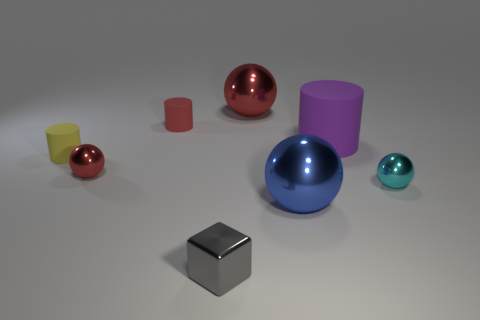How many things are either small gray cubes or things left of the big matte thing? In the image, there is one small gray cube. If we look at the objects positioned to the left of the large cylinder, which appears to be the 'big matte thing,' there are three items: a small yellow cylinder, a small red sphere, and a small red cylinder. Together, that totals four items following the criteria specified. 